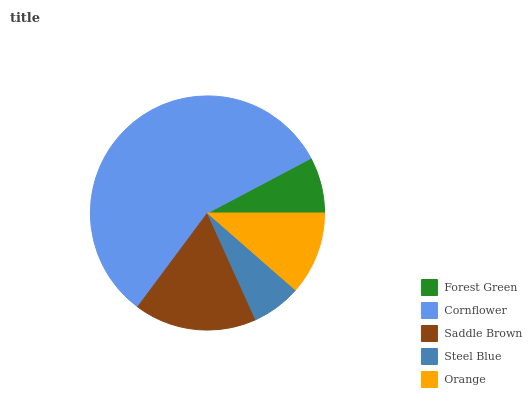Is Steel Blue the minimum?
Answer yes or no. Yes. Is Cornflower the maximum?
Answer yes or no. Yes. Is Saddle Brown the minimum?
Answer yes or no. No. Is Saddle Brown the maximum?
Answer yes or no. No. Is Cornflower greater than Saddle Brown?
Answer yes or no. Yes. Is Saddle Brown less than Cornflower?
Answer yes or no. Yes. Is Saddle Brown greater than Cornflower?
Answer yes or no. No. Is Cornflower less than Saddle Brown?
Answer yes or no. No. Is Orange the high median?
Answer yes or no. Yes. Is Orange the low median?
Answer yes or no. Yes. Is Cornflower the high median?
Answer yes or no. No. Is Steel Blue the low median?
Answer yes or no. No. 